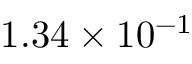<formula> <loc_0><loc_0><loc_500><loc_500>1 . 3 4 \times 1 0 ^ { - 1 }</formula> 